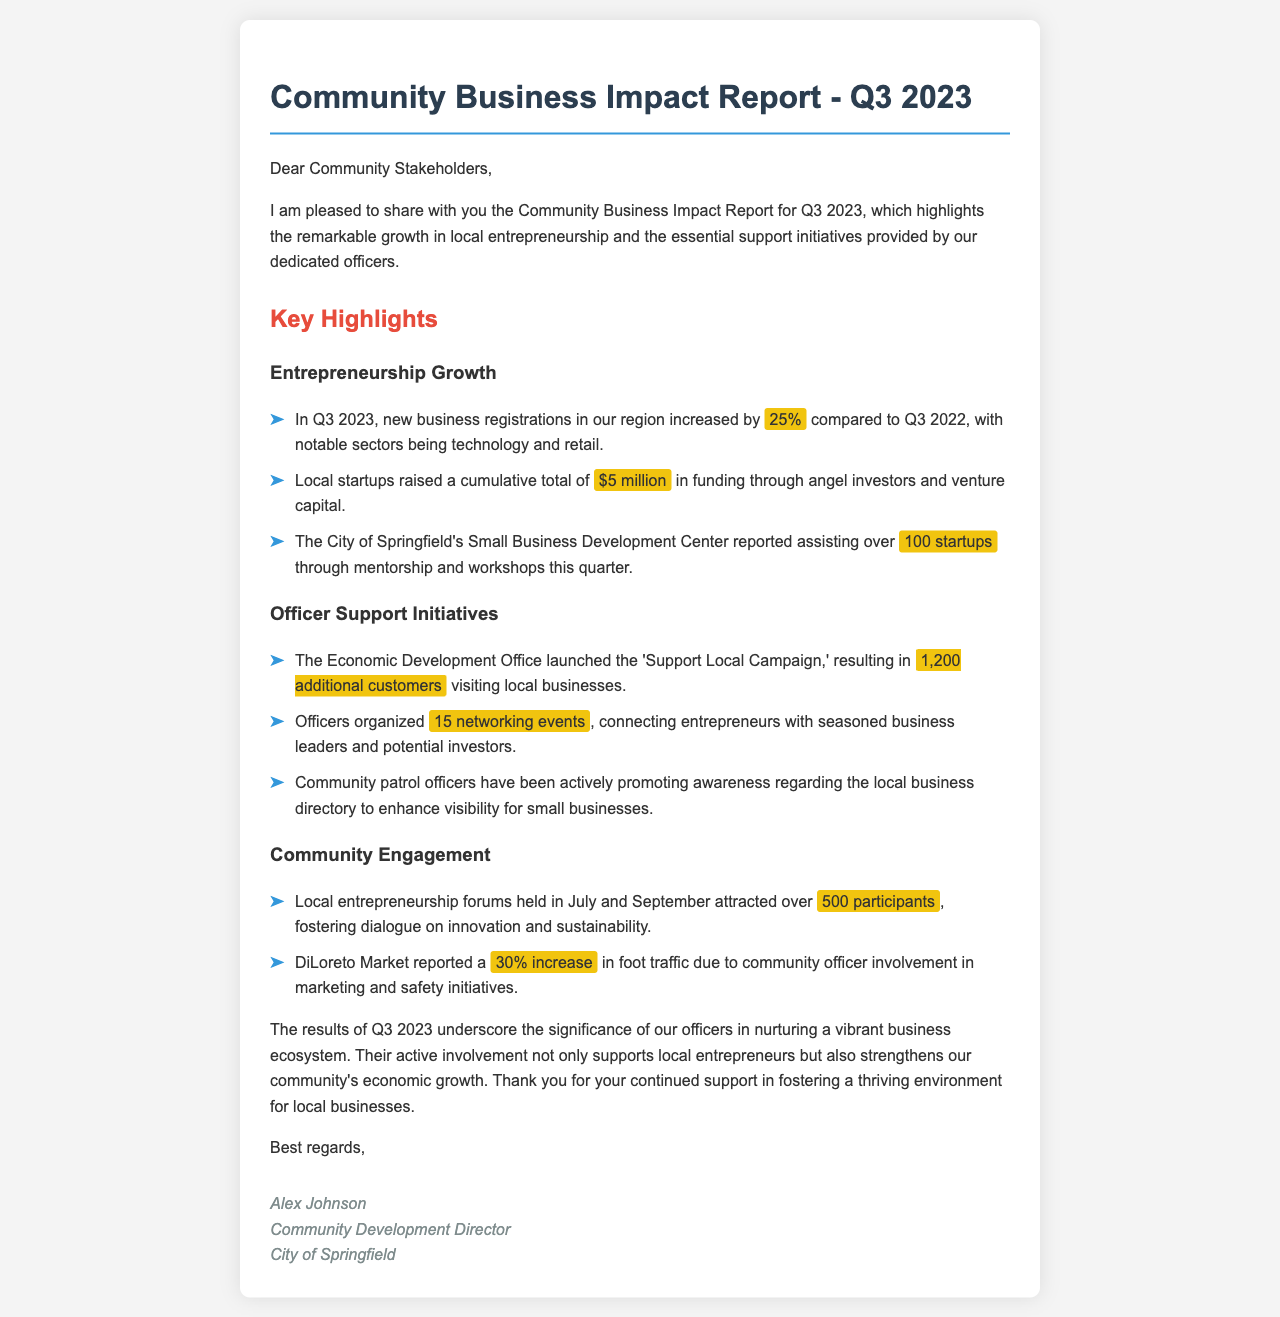What percentage did new business registrations increase in Q3 2023 compared to Q3 2022? The document states that new business registrations increased by 25% in Q3 2023 compared to Q3 2022.
Answer: 25% How much funding did local startups raise in Q3 2023? The document mentions that local startups raised a cumulative total of $5 million in funding in Q3 2023.
Answer: $5 million How many startups were assisted by the Small Business Development Center? According to the report, the Small Business Development Center assisted over 100 startups in Q3 2023.
Answer: 100 What was the outcome of the 'Support Local Campaign'? The document states that the campaign resulted in 1,200 additional customers visiting local businesses.
Answer: 1,200 additional customers How many networking events did officers organize? The report highlights that officers organized 15 networking events during Q3 2023.
Answer: 15 What was the attendance for local entrepreneurship forums held in July and September? The document indicates that over 500 participants attended the local entrepreneurship forums held in July and September.
Answer: 500 participants Which market reported a 30% increase in foot traffic? The report specifies that DiLoreto Market reported a 30% increase in foot traffic.
Answer: DiLoreto Market Who is the Community Development Director? The signature section of the document identifies Alex Johnson as the Community Development Director.
Answer: Alex Johnson What is the primary focus of the Q3 2023 report? The document emphasizes the growth in local entrepreneurship and officer support initiatives as the main focus.
Answer: Local entrepreneurship growth and officer support initiatives 